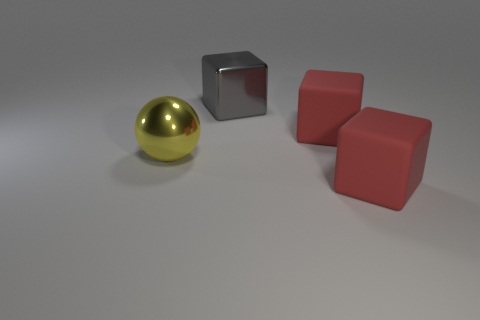Subtract all large matte blocks. How many blocks are left? 1 Add 4 red rubber objects. How many objects exist? 8 Subtract all gray blocks. How many blocks are left? 2 Subtract all balls. How many objects are left? 3 Add 1 gray objects. How many gray objects exist? 2 Subtract 0 green cylinders. How many objects are left? 4 Subtract 2 blocks. How many blocks are left? 1 Subtract all cyan balls. Subtract all yellow blocks. How many balls are left? 1 Subtract all brown cylinders. How many red blocks are left? 2 Subtract all big gray things. Subtract all yellow things. How many objects are left? 2 